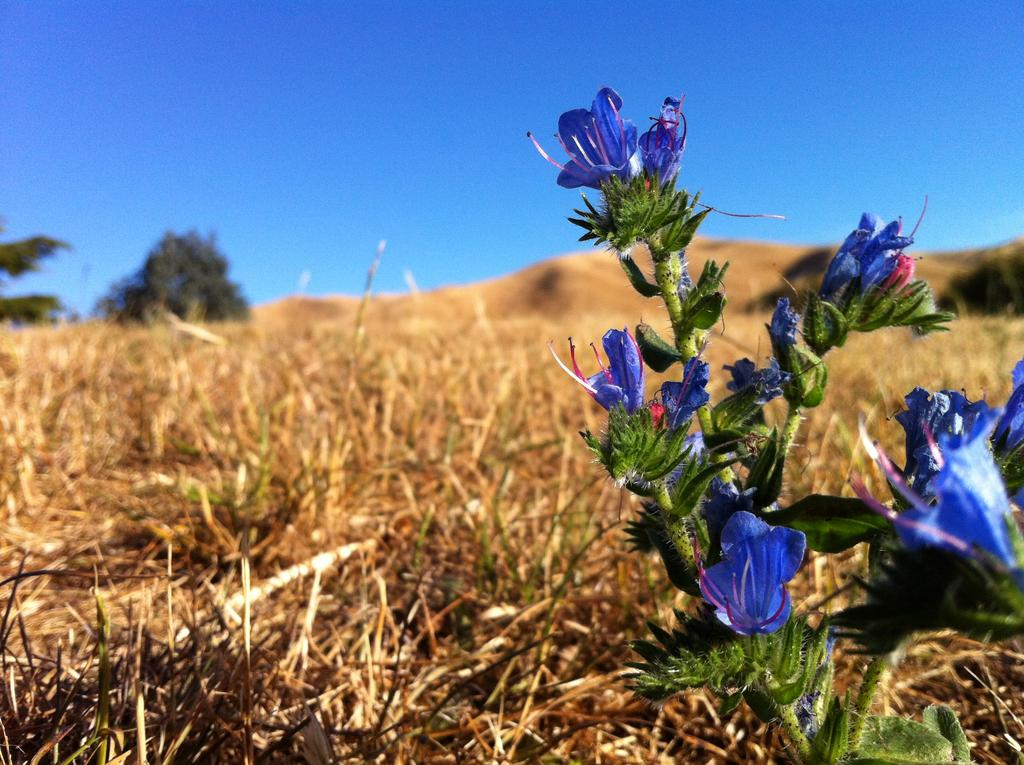What type of flowers can be seen on the right side of the image? There are blue color flowers on a stem on the right side of the image. What is present on the ground in the image? There is grass on the ground in the image. What can be seen in the background of the image? There is a tree and the sky visible in the background of the image. What type of fish can be heard singing in the image? There are no fish present in the image, and therefore no singing can be heard. 